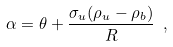Convert formula to latex. <formula><loc_0><loc_0><loc_500><loc_500>\alpha = \theta + \frac { \sigma _ { u } ( \rho _ { u } - \rho _ { b } ) } { R } \ ,</formula> 